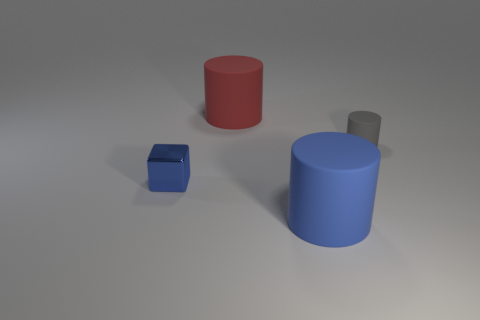Subtract all large red cylinders. How many cylinders are left? 2 Add 3 big red metal balls. How many objects exist? 7 Subtract all cubes. How many objects are left? 3 Subtract all green cylinders. Subtract all red cubes. How many cylinders are left? 3 Subtract all big gray rubber spheres. Subtract all cylinders. How many objects are left? 1 Add 4 large blue rubber cylinders. How many large blue rubber cylinders are left? 5 Add 4 big red objects. How many big red objects exist? 5 Subtract 0 brown cylinders. How many objects are left? 4 